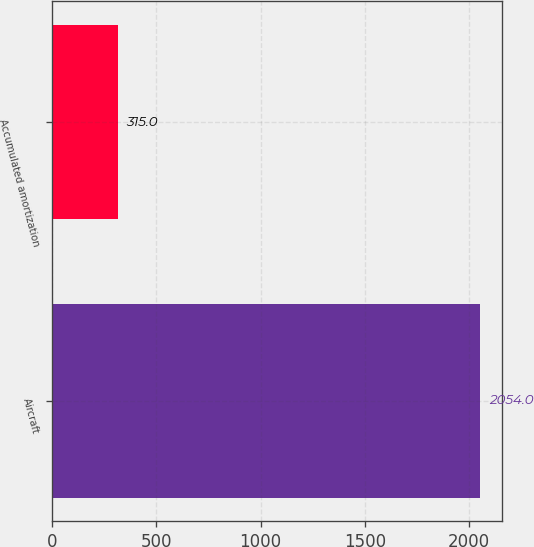<chart> <loc_0><loc_0><loc_500><loc_500><bar_chart><fcel>Aircraft<fcel>Accumulated amortization<nl><fcel>2054<fcel>315<nl></chart> 